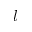Convert formula to latex. <formula><loc_0><loc_0><loc_500><loc_500>l</formula> 